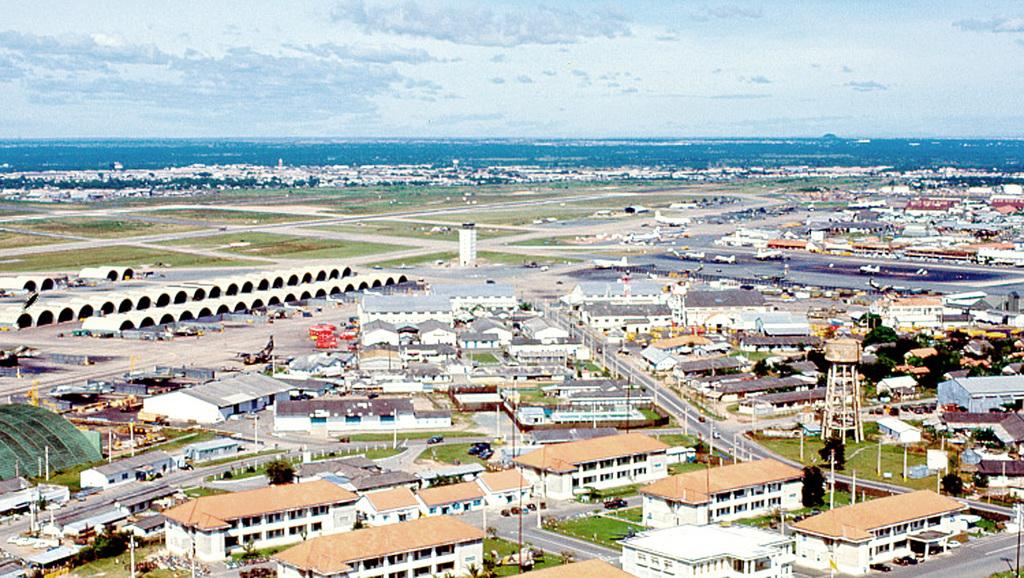What type of structures can be seen in the image? There are many buildings in the image. What other natural elements are present in the image? There are trees in the image. What can be seen in the distance in the image? There is a water body in the background of the image. How would you describe the weather in the image? The sky is cloudy in the image. What type of juice is being served at the downtown event in the image? There is no downtown event or juice present in the image. 